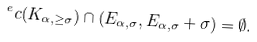Convert formula to latex. <formula><loc_0><loc_0><loc_500><loc_500>^ { e } c ( K _ { \alpha , \geq \sigma } ) \cap ( E _ { \alpha , \sigma } , E _ { \alpha , \sigma } + \sigma ) = \emptyset .</formula> 